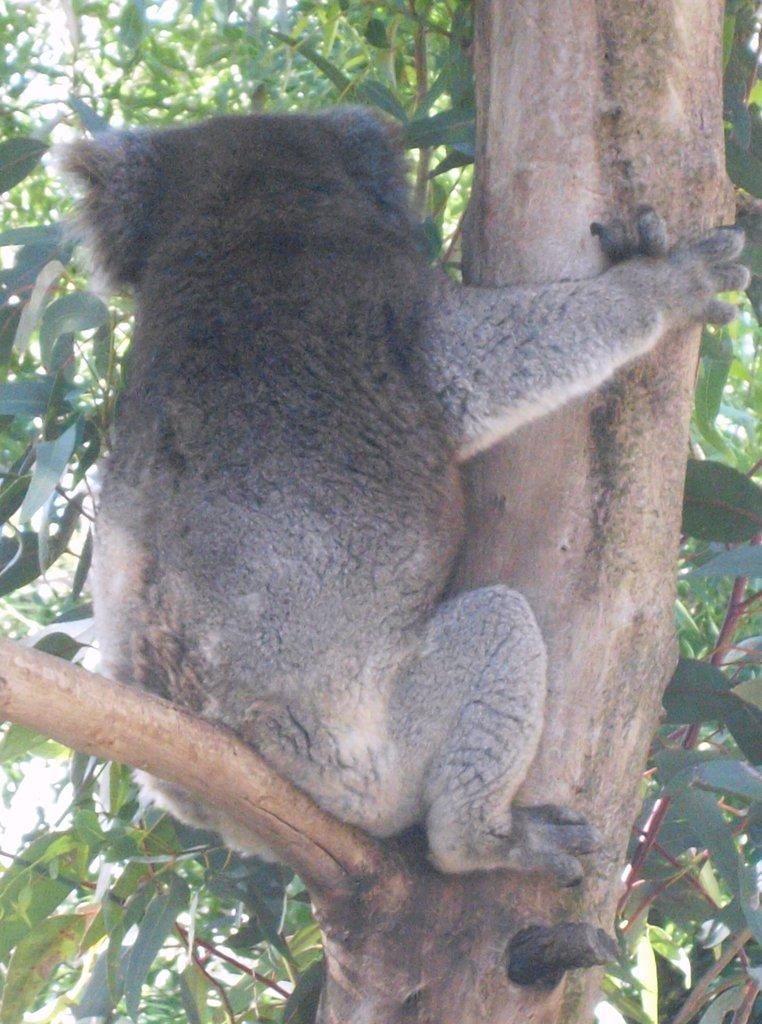What is on the tree in the image? There is an animal on a tree in the image. How many trees are visible in the image? There is only one tree visible in the image. How much debt does the animal on the tree owe in the image? There is no information about debt in the image, as it features an animal on a tree. What type of metal can be seen on the tree in the image? There is no metal, such as copper, present on the tree in the image. 